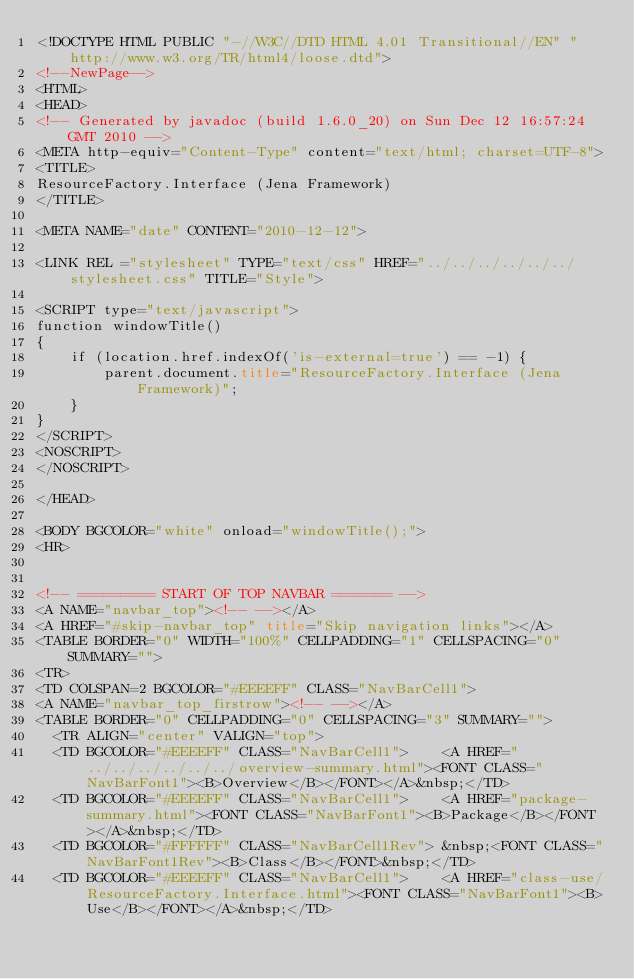<code> <loc_0><loc_0><loc_500><loc_500><_HTML_><!DOCTYPE HTML PUBLIC "-//W3C//DTD HTML 4.01 Transitional//EN" "http://www.w3.org/TR/html4/loose.dtd">
<!--NewPage-->
<HTML>
<HEAD>
<!-- Generated by javadoc (build 1.6.0_20) on Sun Dec 12 16:57:24 GMT 2010 -->
<META http-equiv="Content-Type" content="text/html; charset=UTF-8">
<TITLE>
ResourceFactory.Interface (Jena Framework)
</TITLE>

<META NAME="date" CONTENT="2010-12-12">

<LINK REL ="stylesheet" TYPE="text/css" HREF="../../../../../../stylesheet.css" TITLE="Style">

<SCRIPT type="text/javascript">
function windowTitle()
{
    if (location.href.indexOf('is-external=true') == -1) {
        parent.document.title="ResourceFactory.Interface (Jena Framework)";
    }
}
</SCRIPT>
<NOSCRIPT>
</NOSCRIPT>

</HEAD>

<BODY BGCOLOR="white" onload="windowTitle();">
<HR>


<!-- ========= START OF TOP NAVBAR ======= -->
<A NAME="navbar_top"><!-- --></A>
<A HREF="#skip-navbar_top" title="Skip navigation links"></A>
<TABLE BORDER="0" WIDTH="100%" CELLPADDING="1" CELLSPACING="0" SUMMARY="">
<TR>
<TD COLSPAN=2 BGCOLOR="#EEEEFF" CLASS="NavBarCell1">
<A NAME="navbar_top_firstrow"><!-- --></A>
<TABLE BORDER="0" CELLPADDING="0" CELLSPACING="3" SUMMARY="">
  <TR ALIGN="center" VALIGN="top">
  <TD BGCOLOR="#EEEEFF" CLASS="NavBarCell1">    <A HREF="../../../../../../overview-summary.html"><FONT CLASS="NavBarFont1"><B>Overview</B></FONT></A>&nbsp;</TD>
  <TD BGCOLOR="#EEEEFF" CLASS="NavBarCell1">    <A HREF="package-summary.html"><FONT CLASS="NavBarFont1"><B>Package</B></FONT></A>&nbsp;</TD>
  <TD BGCOLOR="#FFFFFF" CLASS="NavBarCell1Rev"> &nbsp;<FONT CLASS="NavBarFont1Rev"><B>Class</B></FONT>&nbsp;</TD>
  <TD BGCOLOR="#EEEEFF" CLASS="NavBarCell1">    <A HREF="class-use/ResourceFactory.Interface.html"><FONT CLASS="NavBarFont1"><B>Use</B></FONT></A>&nbsp;</TD></code> 